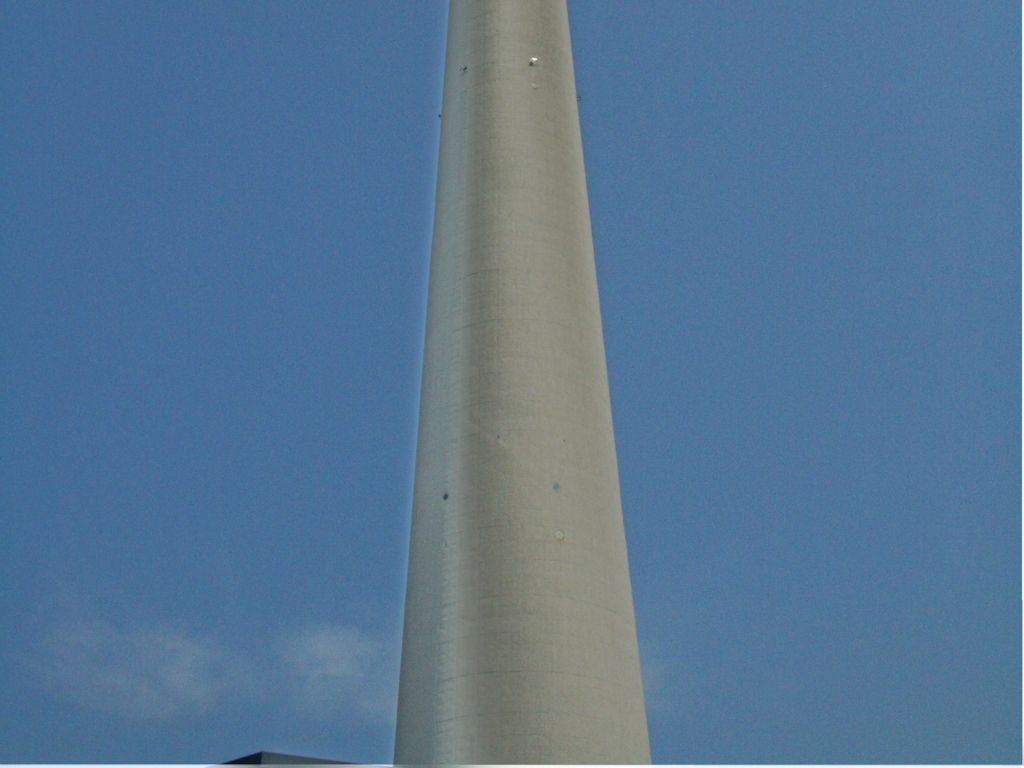Is there anything in the image that indicates the location or environment where this structure stands? The blue sky and absence of any vegetation or distinct geographical features make it challenging to ascertain the location. The fact that there are no discernible weather effects on the structure might imply a temperate climate, but that is speculative without further information. 